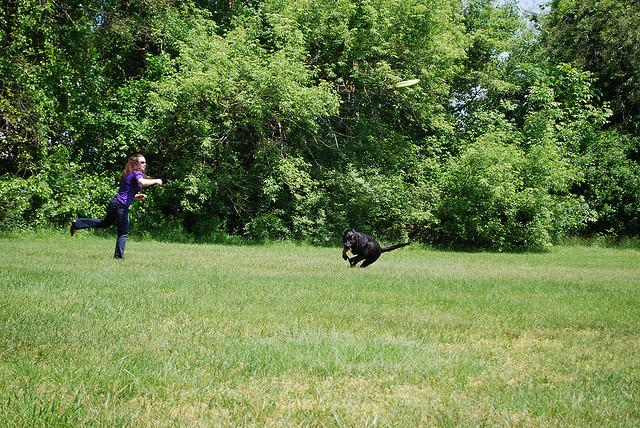What is the woman most likely to be most days of the week?

Choices:
A) spelunker
B) archaeologist
C) animal lover
D) princess animal lover 